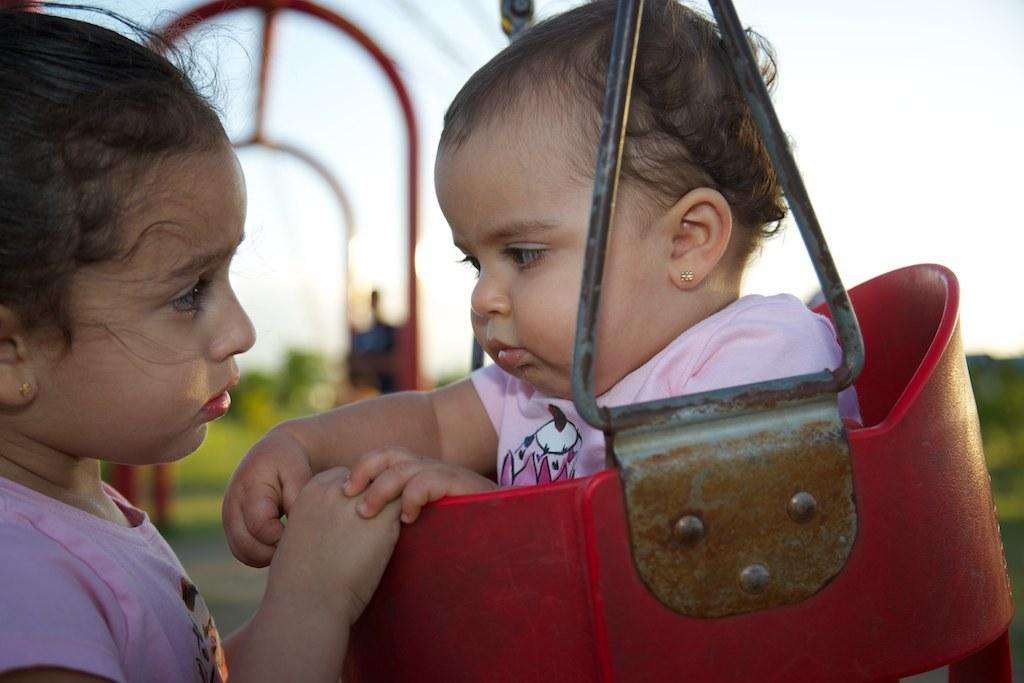What is the baby sitting on in the image? The baby is sitting on a red chair. Who is in front of the baby in the image? There is a girl in front of the baby. Can you describe the background of the image? The background of the image is blurry. What can be seen in the distance in the image? The sky is visible in the background of the image. What type of property does the baby own in the image? There is no indication in the image that the baby owns any property. 